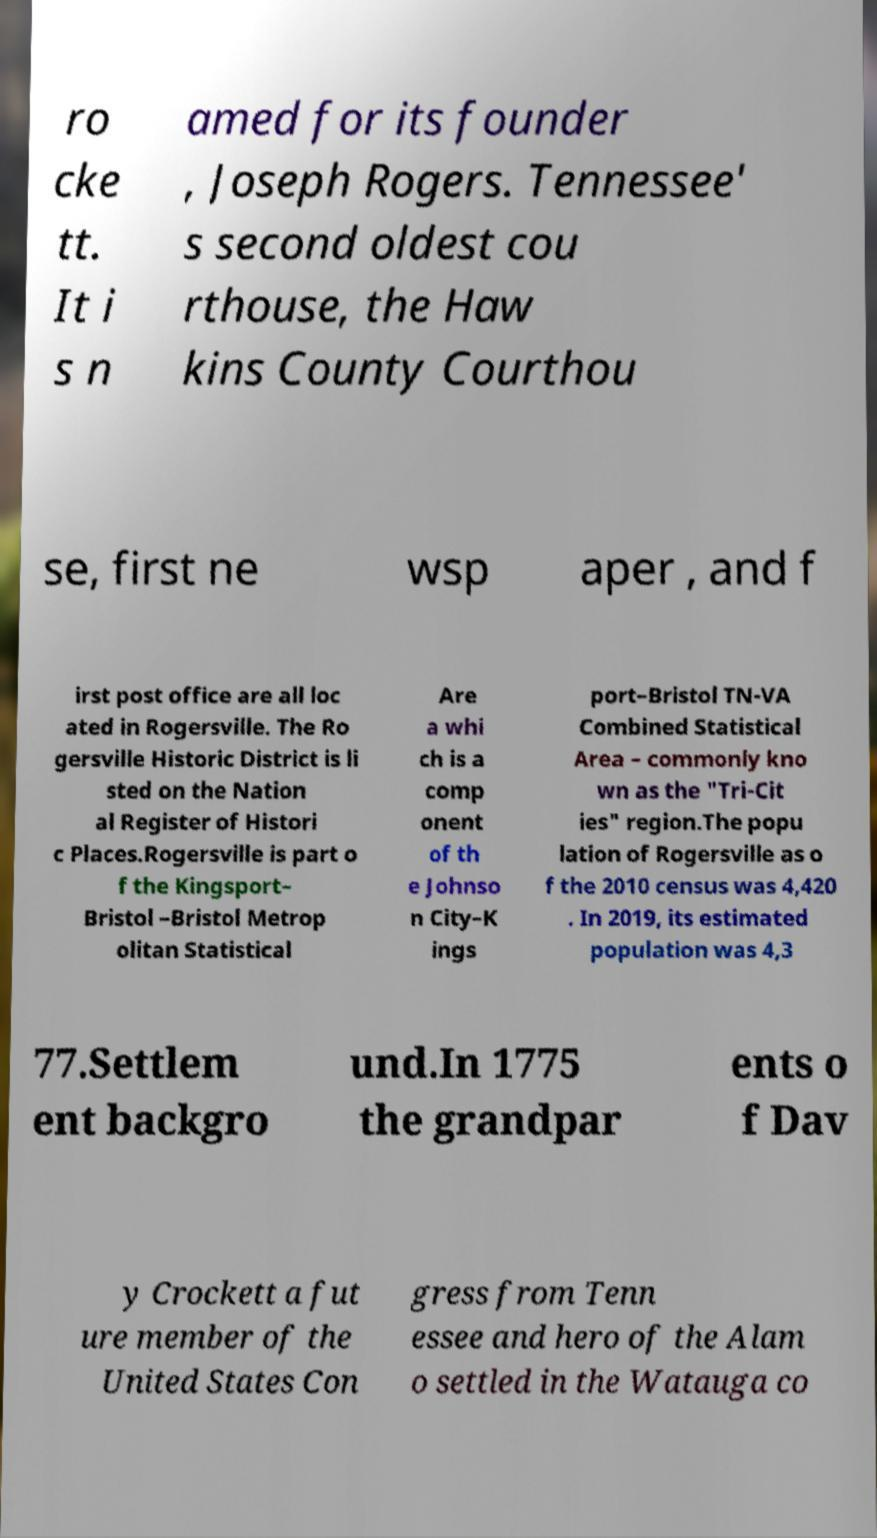I need the written content from this picture converted into text. Can you do that? ro cke tt. It i s n amed for its founder , Joseph Rogers. Tennessee' s second oldest cou rthouse, the Haw kins County Courthou se, first ne wsp aper , and f irst post office are all loc ated in Rogersville. The Ro gersville Historic District is li sted on the Nation al Register of Histori c Places.Rogersville is part o f the Kingsport– Bristol –Bristol Metrop olitan Statistical Are a whi ch is a comp onent of th e Johnso n City–K ings port–Bristol TN-VA Combined Statistical Area – commonly kno wn as the "Tri-Cit ies" region.The popu lation of Rogersville as o f the 2010 census was 4,420 . In 2019, its estimated population was 4,3 77.Settlem ent backgro und.In 1775 the grandpar ents o f Dav y Crockett a fut ure member of the United States Con gress from Tenn essee and hero of the Alam o settled in the Watauga co 